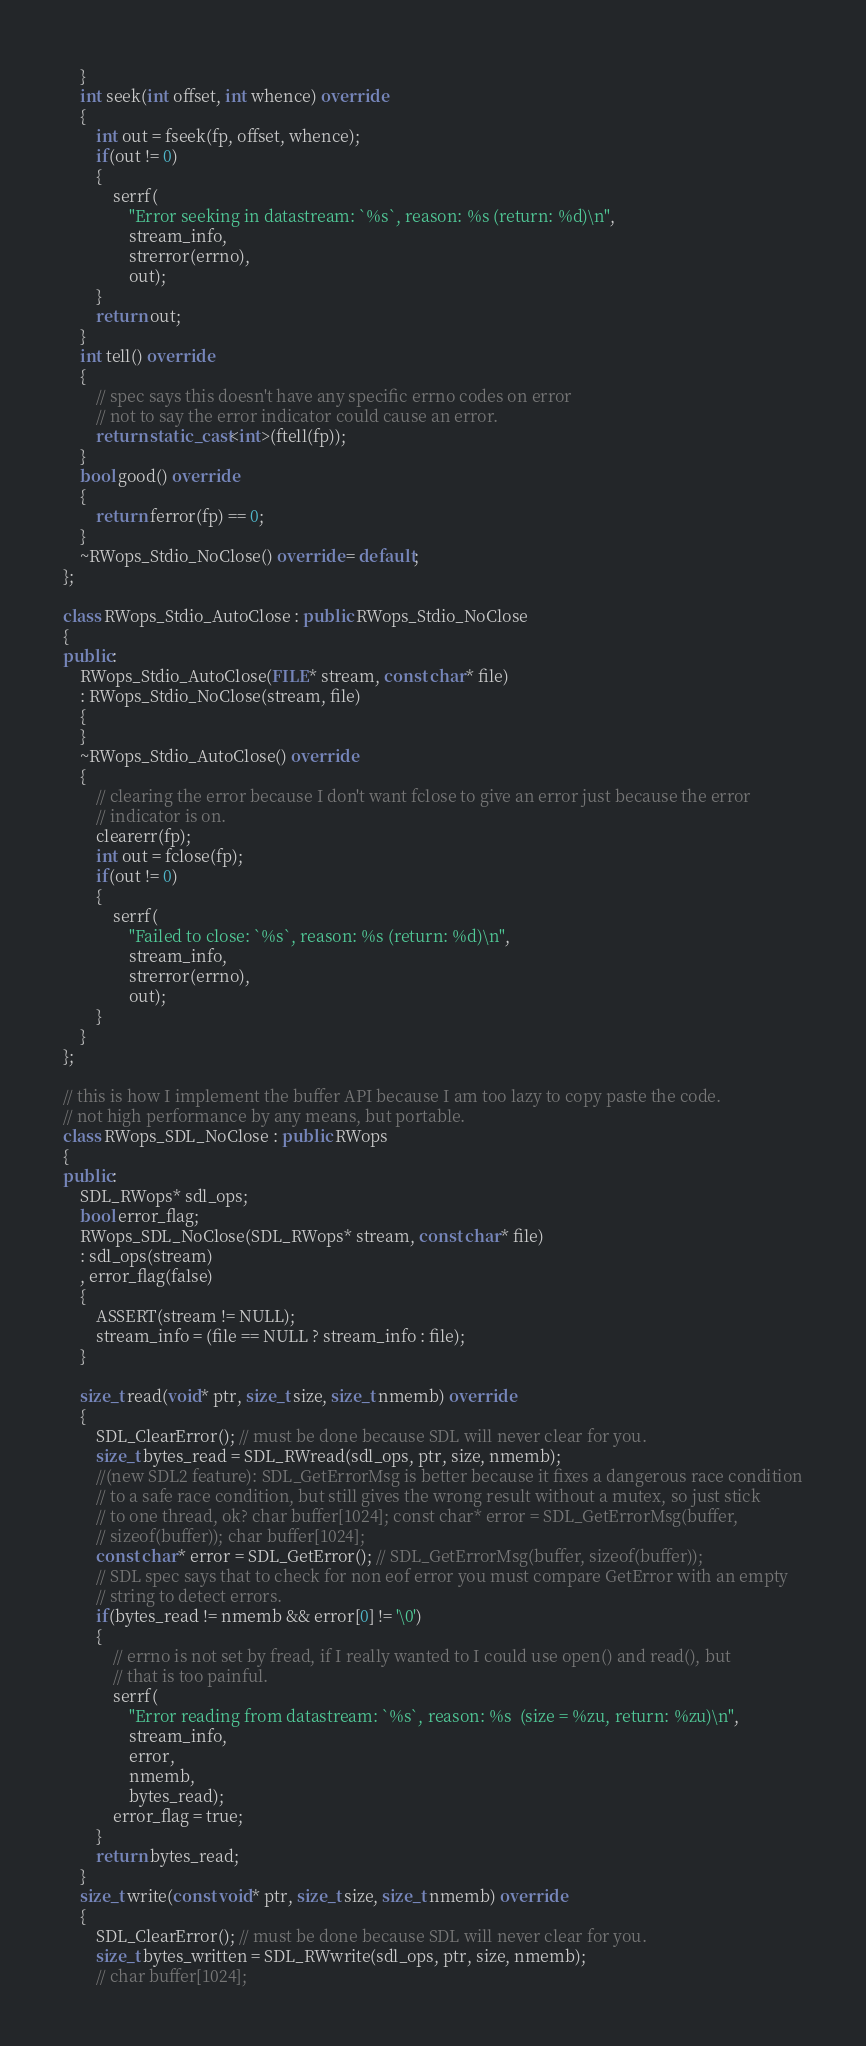Convert code to text. <code><loc_0><loc_0><loc_500><loc_500><_C++_>	}
	int seek(int offset, int whence) override
	{
		int out = fseek(fp, offset, whence);
		if(out != 0)
		{
			serrf(
				"Error seeking in datastream: `%s`, reason: %s (return: %d)\n",
				stream_info,
				strerror(errno),
				out);
		}
		return out;
	}
	int tell() override
	{
		// spec says this doesn't have any specific errno codes on error
		// not to say the error indicator could cause an error.
		return static_cast<int>(ftell(fp));
	}
	bool good() override
	{
		return ferror(fp) == 0;
	}
	~RWops_Stdio_NoClose() override = default;
};

class RWops_Stdio_AutoClose : public RWops_Stdio_NoClose
{
public:
	RWops_Stdio_AutoClose(FILE* stream, const char* file)
	: RWops_Stdio_NoClose(stream, file)
	{
	}
	~RWops_Stdio_AutoClose() override
	{
		// clearing the error because I don't want fclose to give an error just because the error
		// indicator is on.
		clearerr(fp);
		int out = fclose(fp);
		if(out != 0)
		{
			serrf(
				"Failed to close: `%s`, reason: %s (return: %d)\n",
				stream_info,
				strerror(errno),
				out);
		}
	}
};

// this is how I implement the buffer API because I am too lazy to copy paste the code.
// not high performance by any means, but portable.
class RWops_SDL_NoClose : public RWops
{
public:
	SDL_RWops* sdl_ops;
	bool error_flag;
	RWops_SDL_NoClose(SDL_RWops* stream, const char* file)
	: sdl_ops(stream)
	, error_flag(false)
	{
		ASSERT(stream != NULL);
		stream_info = (file == NULL ? stream_info : file);
	}

	size_t read(void* ptr, size_t size, size_t nmemb) override
	{
		SDL_ClearError(); // must be done because SDL will never clear for you.
		size_t bytes_read = SDL_RWread(sdl_ops, ptr, size, nmemb);
		//(new SDL2 feature): SDL_GetErrorMsg is better because it fixes a dangerous race condition
		// to a safe race condition, but still gives the wrong result without a mutex, so just stick
		// to one thread, ok? char buffer[1024]; const char* error = SDL_GetErrorMsg(buffer,
		// sizeof(buffer)); char buffer[1024];
		const char* error = SDL_GetError(); // SDL_GetErrorMsg(buffer, sizeof(buffer));
		// SDL spec says that to check for non eof error you must compare GetError with an empty
		// string to detect errors.
		if(bytes_read != nmemb && error[0] != '\0')
		{
			// errno is not set by fread, if I really wanted to I could use open() and read(), but
			// that is too painful.
			serrf(
				"Error reading from datastream: `%s`, reason: %s  (size = %zu, return: %zu)\n",
				stream_info,
				error,
				nmemb,
				bytes_read);
			error_flag = true;
		}
		return bytes_read;
	}
	size_t write(const void* ptr, size_t size, size_t nmemb) override
	{
		SDL_ClearError(); // must be done because SDL will never clear for you.
		size_t bytes_written = SDL_RWwrite(sdl_ops, ptr, size, nmemb);
		// char buffer[1024];</code> 